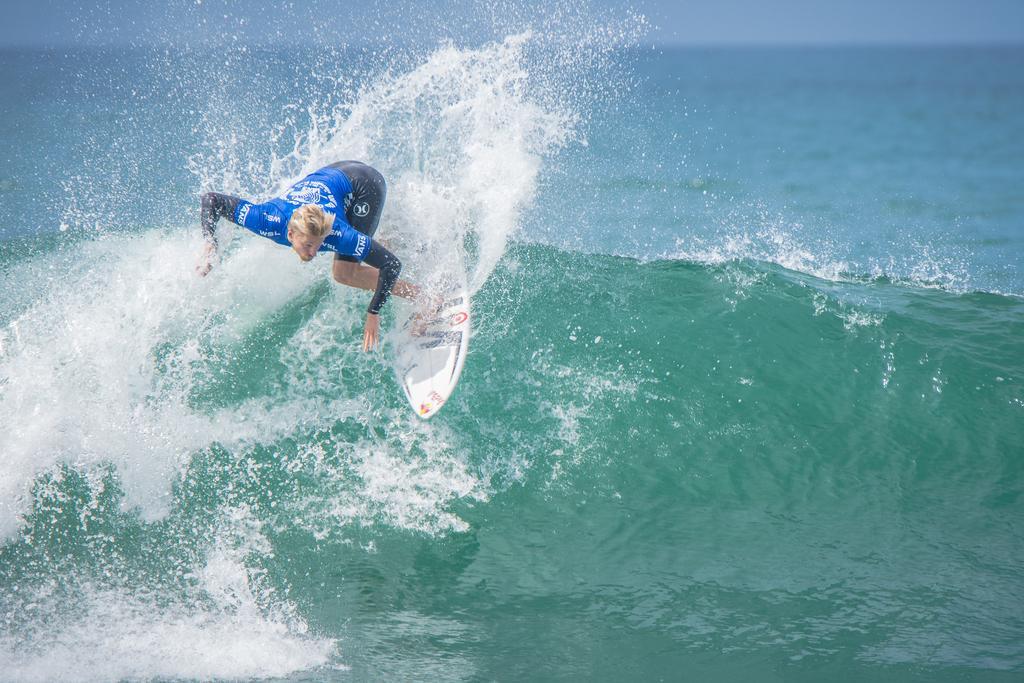In one or two sentences, can you explain what this image depicts? In this image I can see a person on the surfboard, the person is wearing blue and black color dress. Background I can see the water. 